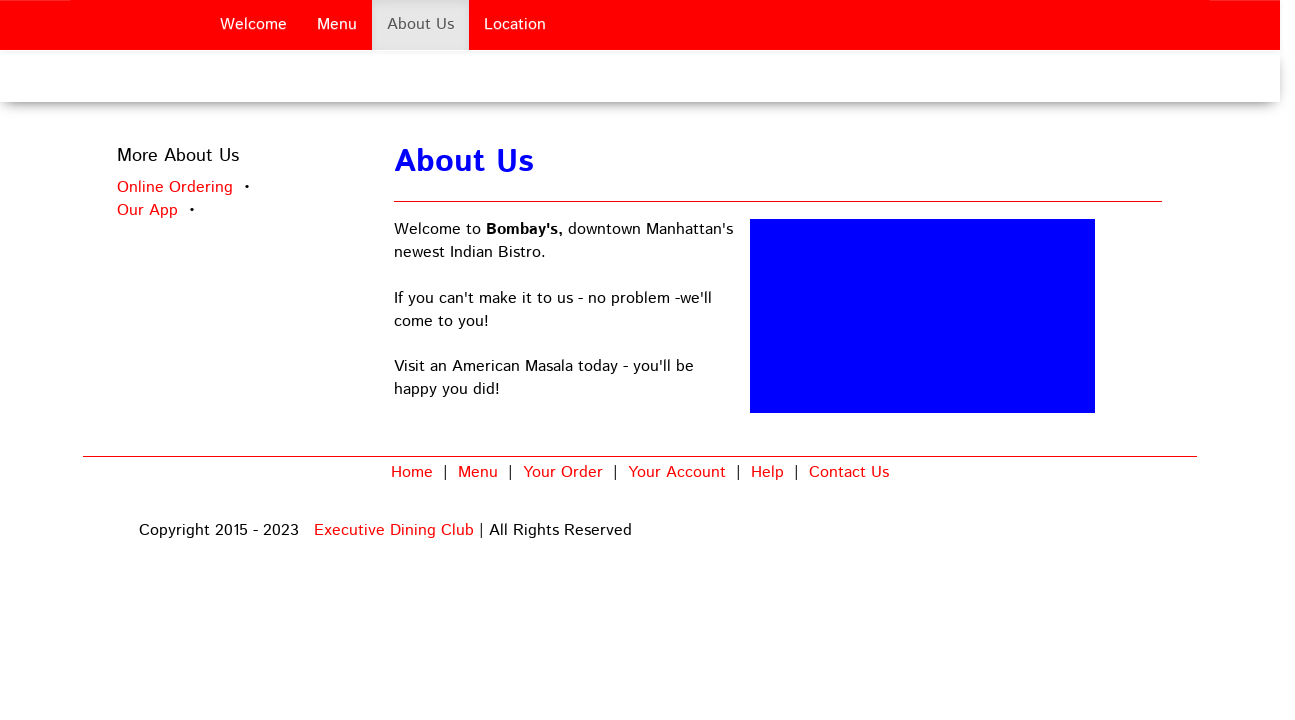Can you explain how the layout of this webpage enhances user experience? The layout of the webpage, with clear, evenly spaced navigation links at the top, ensures visitors can easily find and access different sections like 'Menu', 'About Us', and 'Location'. This streamlined navigation aids in providing a smooth and user-friendly experience, making the website efficient and easy to use. How does the use of large, bold typography in the 'About Us' section benefit the page? Using large, bold typography in the 'About Us' section makes the text eye-catching and readable, which can effectively draw the viewer's attention to important details about the restaurant. This typographical choice helps in emphasizing the restaurant's unique qualities and the narrative of its brand, ensuring the message is communicated clearly and memorably. 